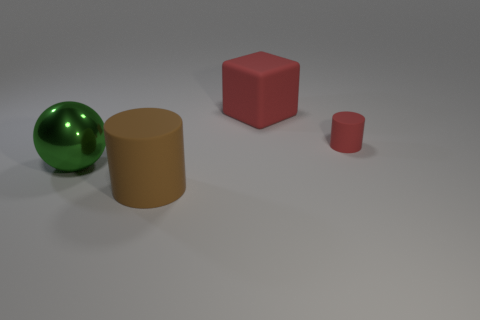Do the brown object and the large green metal thing have the same shape?
Your answer should be very brief. No. How many rubber things are brown objects or green objects?
Give a very brief answer. 1. There is a thing that is the same color as the small cylinder; what is its material?
Your answer should be compact. Rubber. Does the green sphere have the same size as the brown matte cylinder?
Ensure brevity in your answer.  Yes. How many objects are tiny blue rubber cylinders or big things that are behind the big brown rubber thing?
Your answer should be very brief. 2. There is a red cube that is the same size as the metal thing; what material is it?
Give a very brief answer. Rubber. There is a thing that is both in front of the small red cylinder and on the right side of the large green thing; what material is it?
Offer a very short reply. Rubber. Are there any green things right of the large object that is behind the large green object?
Keep it short and to the point. No. There is a object that is both to the left of the big red rubber cube and on the right side of the large green thing; how big is it?
Give a very brief answer. Large. What number of yellow objects are either tiny things or blocks?
Make the answer very short. 0. 